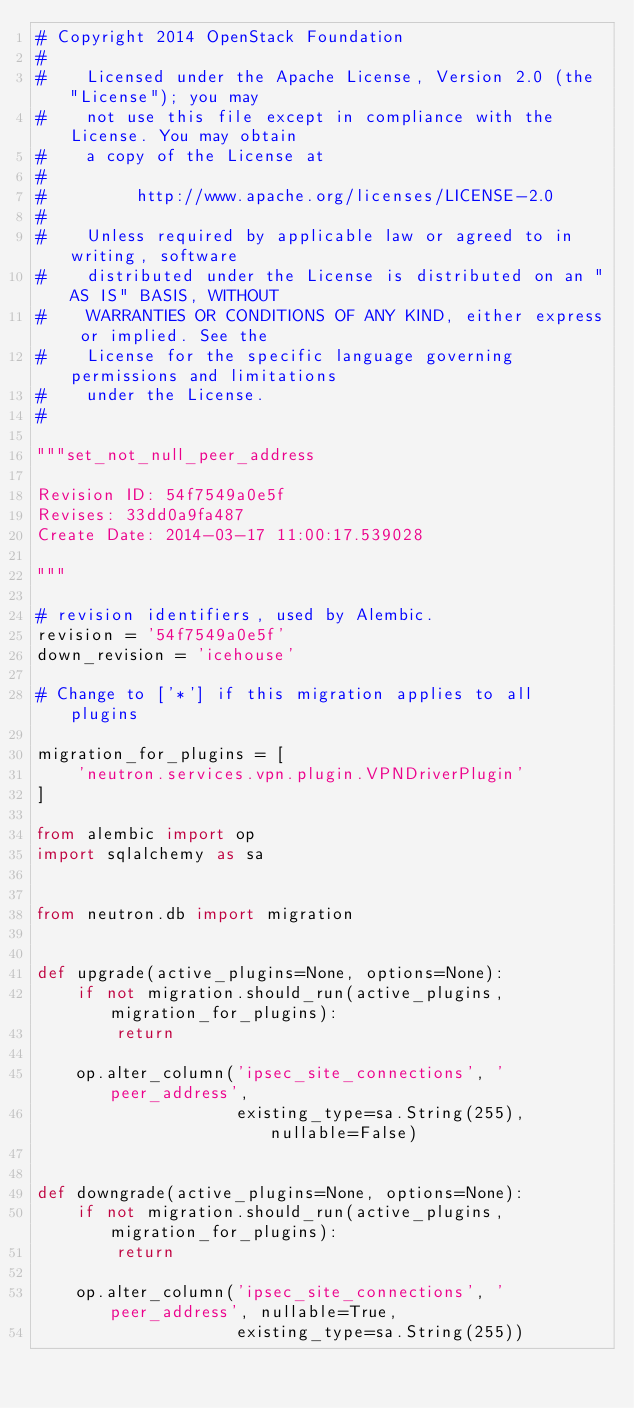Convert code to text. <code><loc_0><loc_0><loc_500><loc_500><_Python_># Copyright 2014 OpenStack Foundation
#
#    Licensed under the Apache License, Version 2.0 (the "License"); you may
#    not use this file except in compliance with the License. You may obtain
#    a copy of the License at
#
#         http://www.apache.org/licenses/LICENSE-2.0
#
#    Unless required by applicable law or agreed to in writing, software
#    distributed under the License is distributed on an "AS IS" BASIS, WITHOUT
#    WARRANTIES OR CONDITIONS OF ANY KIND, either express or implied. See the
#    License for the specific language governing permissions and limitations
#    under the License.
#

"""set_not_null_peer_address

Revision ID: 54f7549a0e5f
Revises: 33dd0a9fa487
Create Date: 2014-03-17 11:00:17.539028

"""

# revision identifiers, used by Alembic.
revision = '54f7549a0e5f'
down_revision = 'icehouse'

# Change to ['*'] if this migration applies to all plugins

migration_for_plugins = [
    'neutron.services.vpn.plugin.VPNDriverPlugin'
]

from alembic import op
import sqlalchemy as sa


from neutron.db import migration


def upgrade(active_plugins=None, options=None):
    if not migration.should_run(active_plugins, migration_for_plugins):
        return

    op.alter_column('ipsec_site_connections', 'peer_address',
                    existing_type=sa.String(255), nullable=False)


def downgrade(active_plugins=None, options=None):
    if not migration.should_run(active_plugins, migration_for_plugins):
        return

    op.alter_column('ipsec_site_connections', 'peer_address', nullable=True,
                    existing_type=sa.String(255))
</code> 